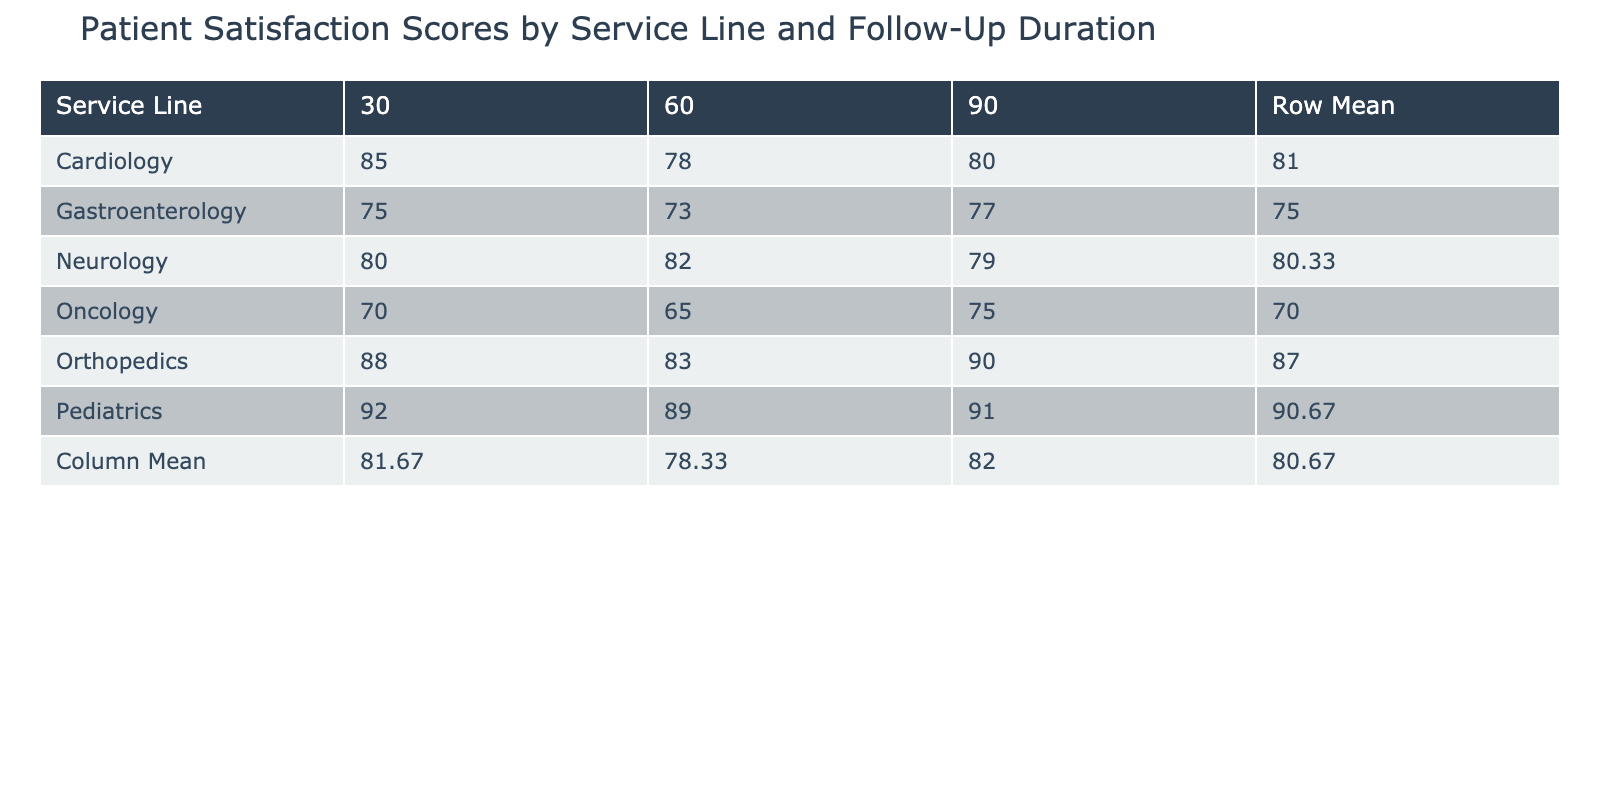What is the patient satisfaction score for Orthopedics with a 90-day follow-up duration? The table shows that for Orthopedics and a follow-up duration of 90 days, the patient satisfaction score is 90.
Answer: 90 What is the row mean for the Cardiology service line? To find the row mean for Cardiology, we take the scores for the follow-up durations (85, 78, 80), sum them up (85 + 78 + 80 = 243) and divide by the number of scores (3). Therefore, 243/3 = 81.
Answer: 81 Is the average patient satisfaction score for Gastroenterology higher than that for Oncology? We need to first calculate the average for both. For Gastroenterology, the scores are (75, 73, 77), summing to 225, and the average is 225/3 = 75. For Oncology, the scores are (70, 65, 75), summing to 210, giving an average of 210/3 = 70. The average for Gastroenterology (75) is indeed higher than for Oncology (70).
Answer: Yes Which service line has the highest patient satisfaction score at a 30-day follow-up duration? Reviewing the scores at the 30-day follow-up, we see that Orthopedics has the highest score of 88, while others are lower: Cardiology (85), Oncology (70), Pediatrics (92), Gastroenterology (75), and Neurology (80). Therefore, Pediatrics has the highest score at this duration.
Answer: Pediatrics What is the difference in the average patient satisfaction scores between Pediatrics and Neurology? First, we find the average for Pediatrics (92, 89, 91, averaging 90.67) and for Neurology (80, 82, 79, averaging 80.33). The difference is 90.67 - 80.33 = 10.34.
Answer: 10.34 True or False: The patient satisfaction score for a 60-day follow-up is never above 89. Looking at the 60-day scores, we find 78 (Cardiology), 65 (Oncology), 83 (Orthopedics), 89 (Pediatrics), 73 (Gastroenterology), and 82 (Neurology). Since the score for Pediatrics reaches 89, the statement is false.
Answer: False Which service line has the lowest patient satisfaction score at a 90-day follow-up duration? The scores for a 90-day follow-up are 80 (Cardiology), 75 (Oncology), 90 (Orthopedics), 91 (Pediatrics), 77 (Gastroenterology), and 79 (Neurology). The lowest score is 75 from Oncology.
Answer: Oncology What is the total patient satisfaction score for Cardiology across all follow-up durations? Summing the scores for Cardiology (85 + 78 + 80), we get 243. Therefore, the total patient satisfaction score is 243.
Answer: 243 What is the column mean for the 60-day follow-up duration? The scores at the 60-day follow-up for each service line are 78 (Cardiology), 65 (Oncology), 83 (Orthopedics), 89 (Pediatrics), 73 (Gastroenterology), and 82 (Neurology). Summing these (78 + 65 + 83 + 89 + 73 + 82 = 470) and averaging by dividing by the number of service lines (6), we get 470/6 = 78.33.
Answer: 78.33 